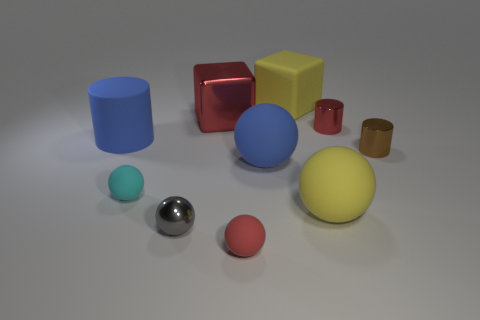Subtract all red balls. How many balls are left? 4 Subtract all large blue matte spheres. How many spheres are left? 4 Subtract all cyan balls. Subtract all red cylinders. How many balls are left? 4 Subtract all blocks. How many objects are left? 8 Subtract 1 red balls. How many objects are left? 9 Subtract all red metal cubes. Subtract all gray metal things. How many objects are left? 8 Add 1 small red objects. How many small red objects are left? 3 Add 5 big purple matte blocks. How many big purple matte blocks exist? 5 